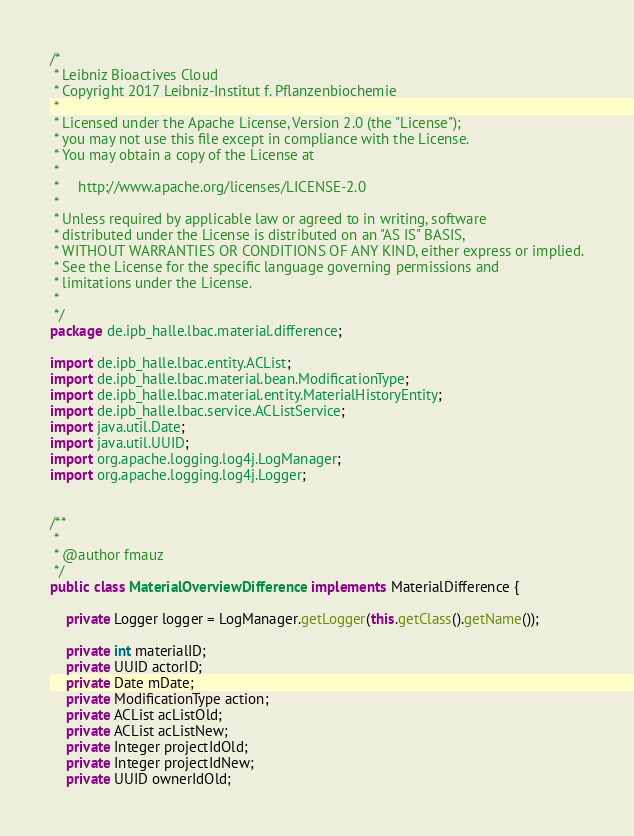Convert code to text. <code><loc_0><loc_0><loc_500><loc_500><_Java_>/*
 * Leibniz Bioactives Cloud
 * Copyright 2017 Leibniz-Institut f. Pflanzenbiochemie
 *
 * Licensed under the Apache License, Version 2.0 (the "License");
 * you may not use this file except in compliance with the License.
 * You may obtain a copy of the License at
 *
 *     http://www.apache.org/licenses/LICENSE-2.0
 *
 * Unless required by applicable law or agreed to in writing, software
 * distributed under the License is distributed on an "AS IS" BASIS,
 * WITHOUT WARRANTIES OR CONDITIONS OF ANY KIND, either express or implied.
 * See the License for the specific language governing permissions and
 * limitations under the License.
 *
 */
package de.ipb_halle.lbac.material.difference;

import de.ipb_halle.lbac.entity.ACList;
import de.ipb_halle.lbac.material.bean.ModificationType;
import de.ipb_halle.lbac.material.entity.MaterialHistoryEntity;
import de.ipb_halle.lbac.service.ACListService;
import java.util.Date;
import java.util.UUID;
import org.apache.logging.log4j.LogManager;
import org.apache.logging.log4j.Logger;


/**
 *
 * @author fmauz
 */
public class MaterialOverviewDifference implements MaterialDifference {

    private Logger logger = LogManager.getLogger(this.getClass().getName());

    private int materialID;
    private UUID actorID;
    private Date mDate;
    private ModificationType action;
    private ACList acListOld;
    private ACList acListNew;
    private Integer projectIdOld;
    private Integer projectIdNew;
    private UUID ownerIdOld;</code> 